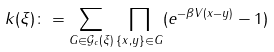<formula> <loc_0><loc_0><loc_500><loc_500>k ( \xi ) \colon = \sum _ { G \in \mathcal { G } _ { c } ( \xi ) } \prod _ { \{ x , y \} \in G } ( e ^ { - \beta V ( x - y ) } - 1 )</formula> 